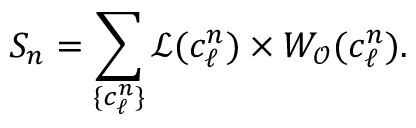Convert formula to latex. <formula><loc_0><loc_0><loc_500><loc_500>S _ { n } = \sum _ { \{ c _ { \ell } ^ { n } \} } \mathcal { L } ( c _ { \ell } ^ { n } ) \times W _ { \mathcal { O } } ( c _ { \ell } ^ { n } ) .</formula> 